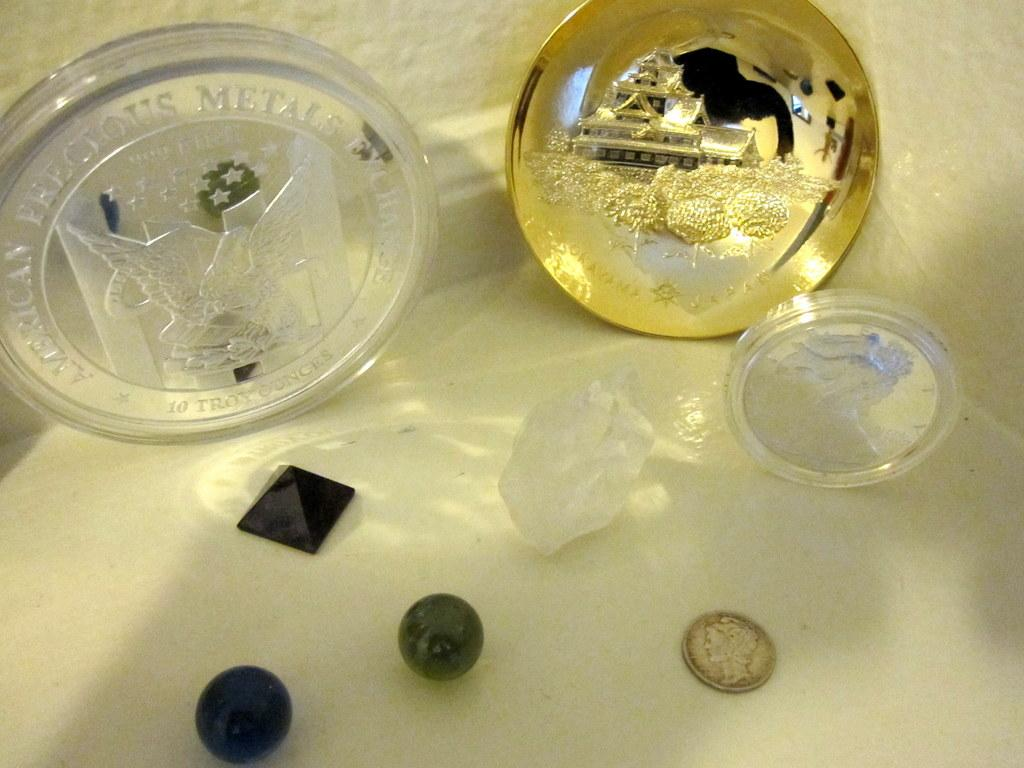<image>
Create a compact narrative representing the image presented. Coins for the American Precious Metals Exchange sit on a white table. 